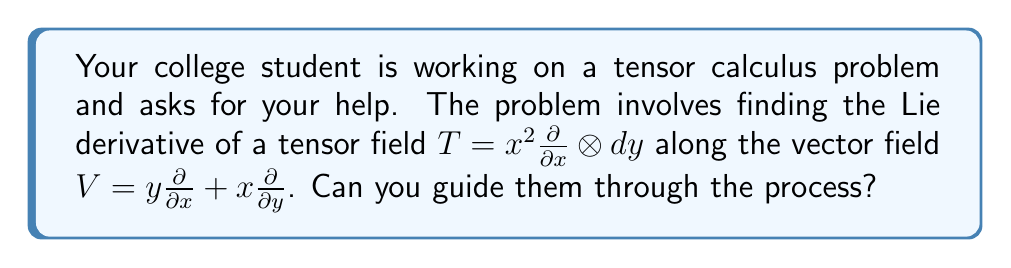Teach me how to tackle this problem. Let's break this down step-by-step:

1) The Lie derivative of a tensor field $T$ along a vector field $V$ is given by:

   $$\mathcal{L}_V T = V(T) + [V, T]$$

   where $V(T)$ is the directional derivative and $[V, T]$ is the Lie bracket.

2) For our tensor $T = x^2 \frac{\partial}{\partial x} \otimes dy$, we need to calculate:

   a) $V(T) = (y \frac{\partial}{\partial x} + x \frac{\partial}{\partial y})(x^2 \frac{\partial}{\partial x} \otimes dy)$
   
   b) $[V, T] = [y \frac{\partial}{\partial x} + x \frac{\partial}{\partial y}, x^2 \frac{\partial}{\partial x}] \otimes dy$

3) Let's start with $V(T)$:
   
   $$V(T) = y \frac{\partial}{\partial x}(x^2) \frac{\partial}{\partial x} \otimes dy + x^2 \frac{\partial}{\partial x} \otimes d(y \frac{\partial}{\partial x} + x \frac{\partial}{\partial y})(y)$$
   
   $$= 2xy \frac{\partial}{\partial x} \otimes dy + x^2 \frac{\partial}{\partial x} \otimes dx$$

4) Now for the Lie bracket $[V, T]$:

   $$[V, T] = [y \frac{\partial}{\partial x} + x \frac{\partial}{\partial y}, x^2 \frac{\partial}{\partial x}] \otimes dy$$
   
   $$= (y \frac{\partial}{\partial x} + x \frac{\partial}{\partial y})(x^2 \frac{\partial}{\partial x}) - x^2 \frac{\partial}{\partial x}(y \frac{\partial}{\partial x} + x \frac{\partial}{\partial y})$$
   
   $$= (2xy \frac{\partial}{\partial x}) - (x^2 \frac{\partial}{\partial x}) \otimes dy$$

5) Combining the results from steps 3 and 4:

   $$\mathcal{L}_V T = V(T) + [V, T]$$
   
   $$= (2xy \frac{\partial}{\partial x} \otimes dy + x^2 \frac{\partial}{\partial x} \otimes dx) + (2xy \frac{\partial}{\partial x} - x^2 \frac{\partial}{\partial x}) \otimes dy$$
   
   $$= 4xy \frac{\partial}{\partial x} \otimes dy + x^2 \frac{\partial}{\partial x} \otimes dx$$

This is the final result for the Lie derivative of $T$ along $V$.
Answer: $4xy \frac{\partial}{\partial x} \otimes dy + x^2 \frac{\partial}{\partial x} \otimes dx$ 